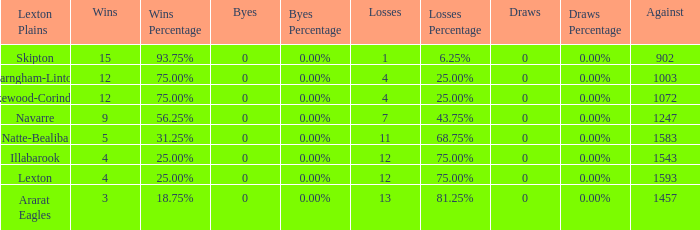What is the most wins with 0 byes? None. 